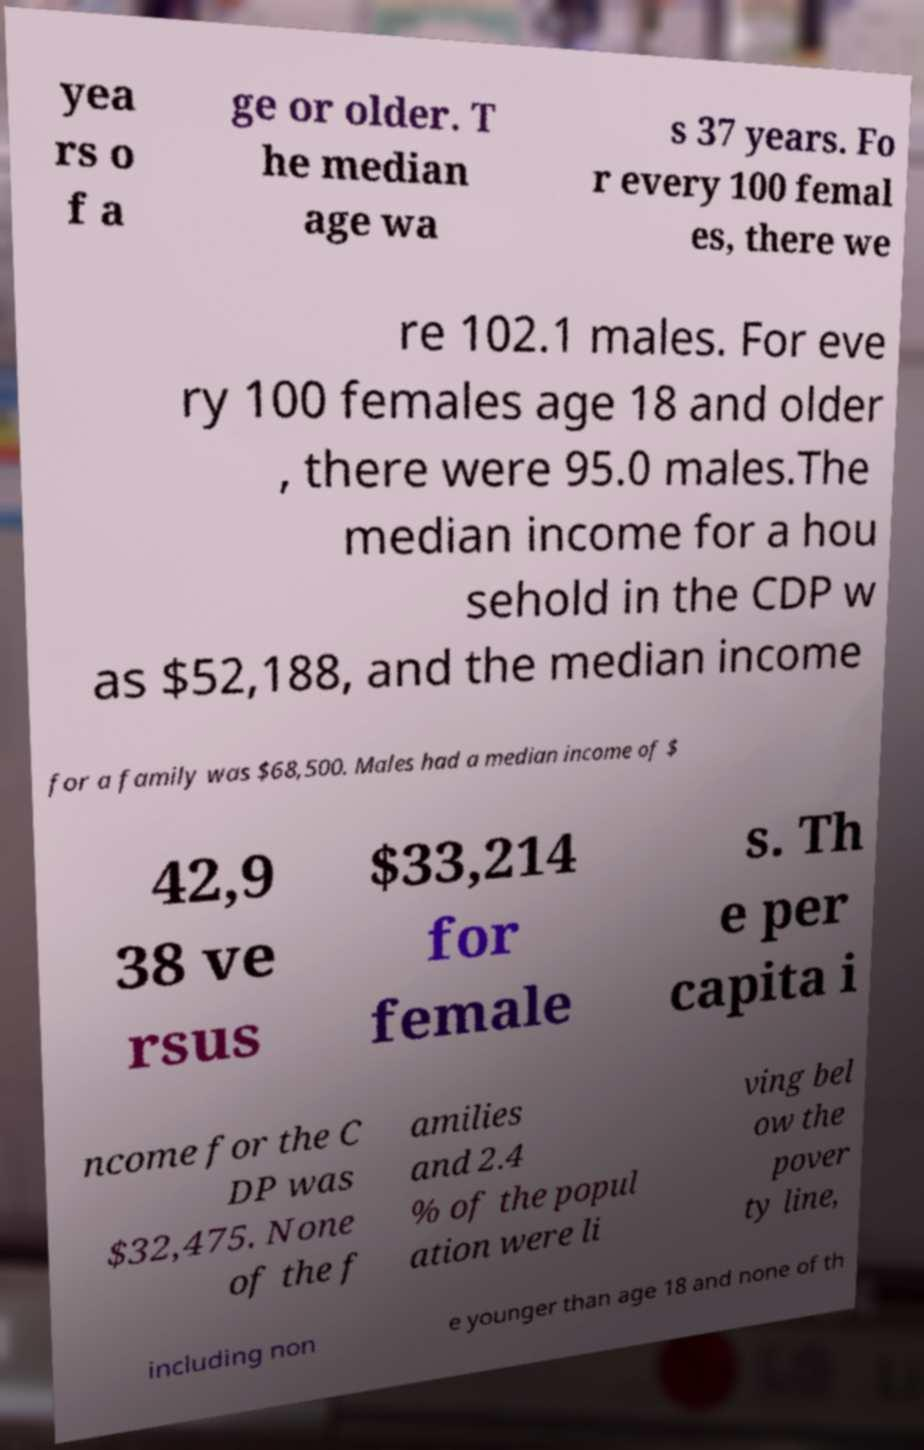Can you accurately transcribe the text from the provided image for me? yea rs o f a ge or older. T he median age wa s 37 years. Fo r every 100 femal es, there we re 102.1 males. For eve ry 100 females age 18 and older , there were 95.0 males.The median income for a hou sehold in the CDP w as $52,188, and the median income for a family was $68,500. Males had a median income of $ 42,9 38 ve rsus $33,214 for female s. Th e per capita i ncome for the C DP was $32,475. None of the f amilies and 2.4 % of the popul ation were li ving bel ow the pover ty line, including non e younger than age 18 and none of th 